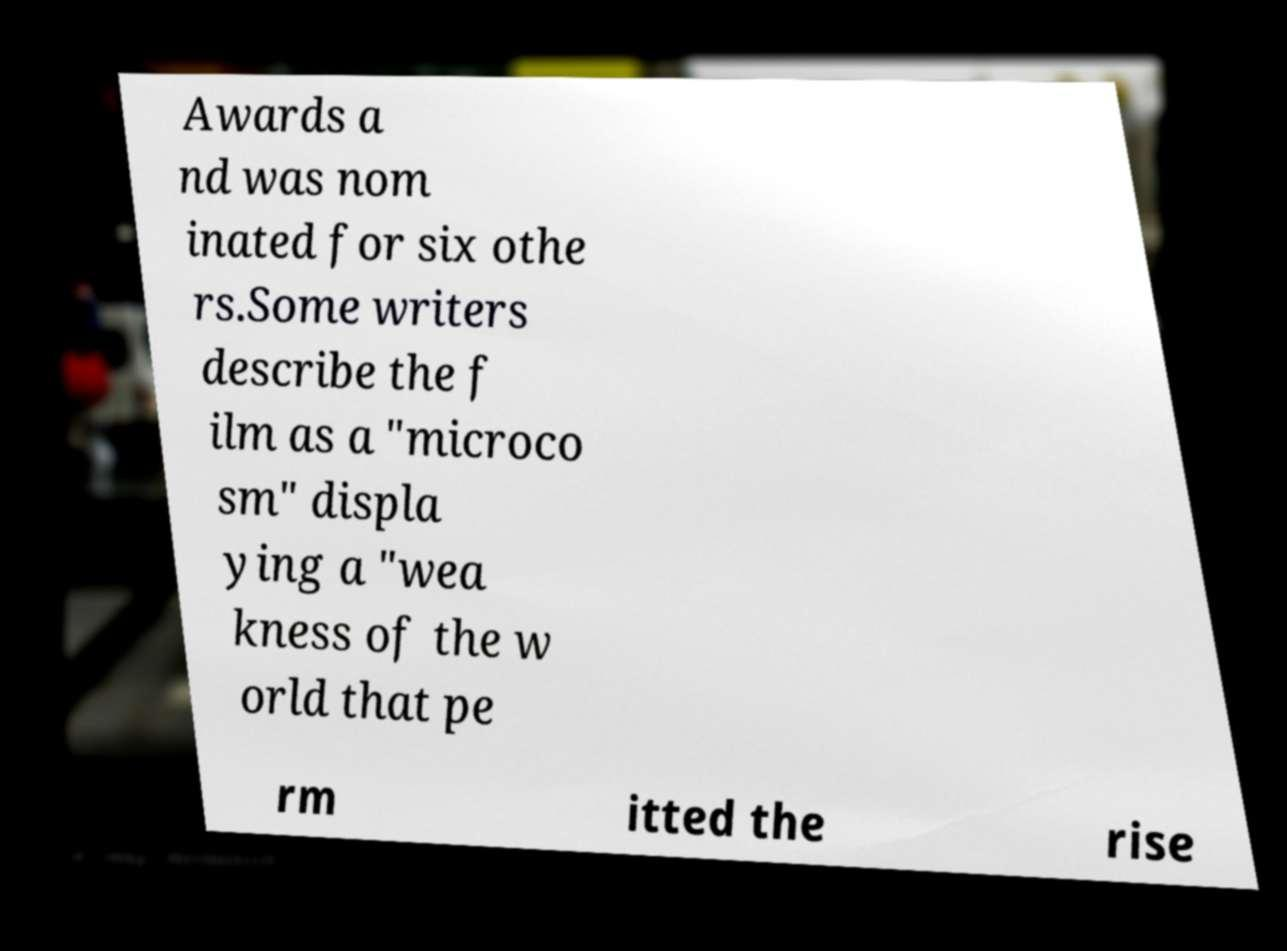Please read and relay the text visible in this image. What does it say? Awards a nd was nom inated for six othe rs.Some writers describe the f ilm as a "microco sm" displa ying a "wea kness of the w orld that pe rm itted the rise 